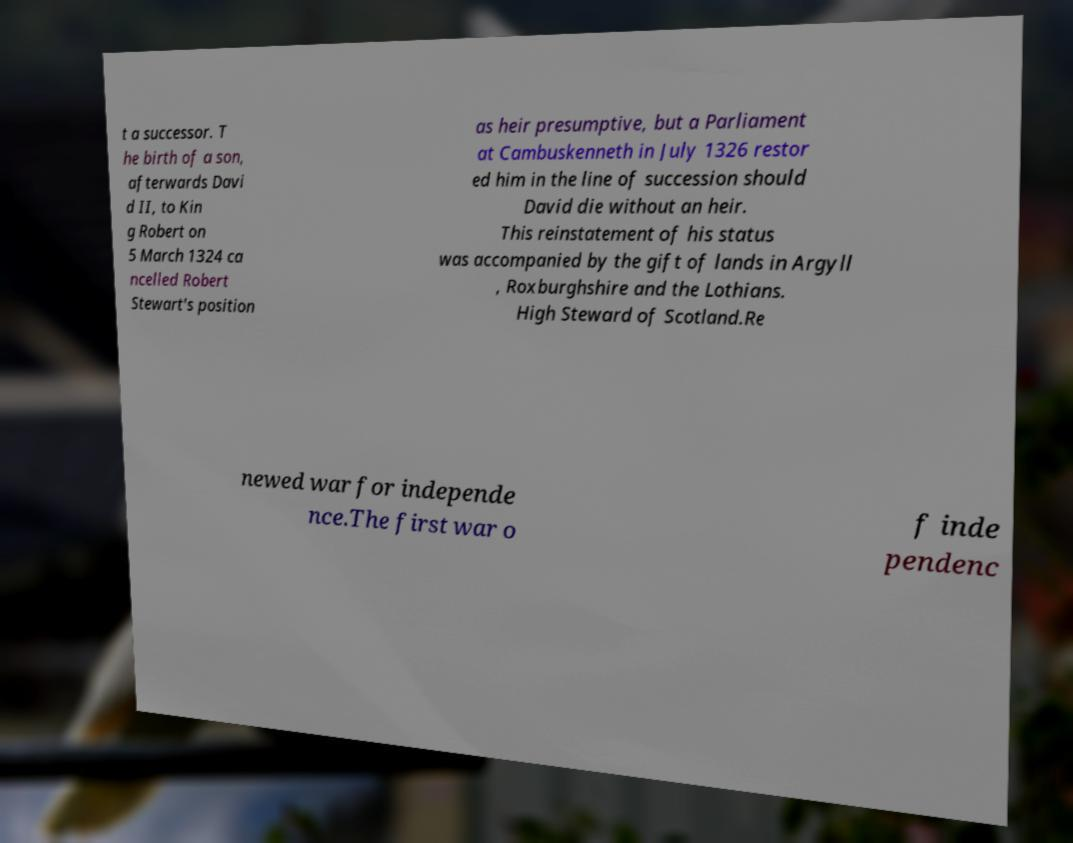Can you accurately transcribe the text from the provided image for me? t a successor. T he birth of a son, afterwards Davi d II, to Kin g Robert on 5 March 1324 ca ncelled Robert Stewart's position as heir presumptive, but a Parliament at Cambuskenneth in July 1326 restor ed him in the line of succession should David die without an heir. This reinstatement of his status was accompanied by the gift of lands in Argyll , Roxburghshire and the Lothians. High Steward of Scotland.Re newed war for independe nce.The first war o f inde pendenc 